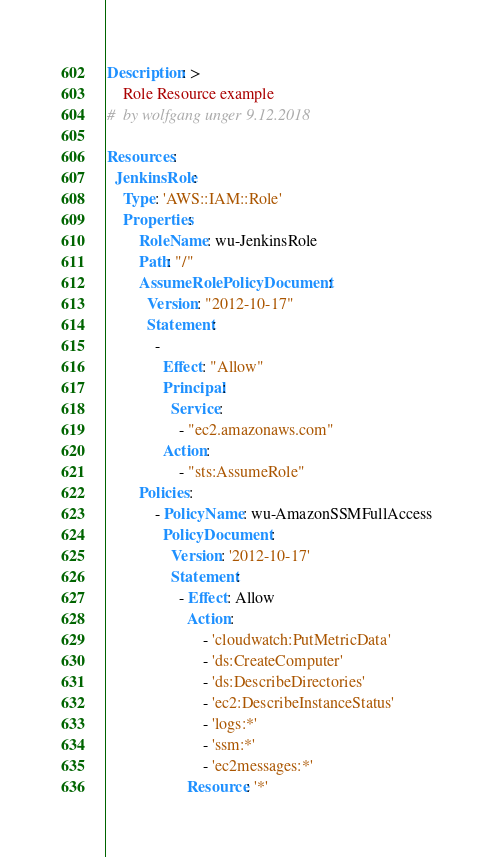<code> <loc_0><loc_0><loc_500><loc_500><_YAML_>
Description: >
    Role Resource example
#  by wolfgang unger 9.12.2018

Resources:
  JenkinsRole:
    Type: 'AWS::IAM::Role'
    Properties:
        RoleName: wu-JenkinsRole    
        Path: "/"    
        AssumeRolePolicyDocument: 
          Version: "2012-10-17"
          Statement: 
            - 
              Effect: "Allow"
              Principal: 
                Service: 
                  - "ec2.amazonaws.com"
              Action: 
                  - "sts:AssumeRole" 
        Policies:
            - PolicyName: wu-AmazonSSMFullAccess
              PolicyDocument:
                Version: '2012-10-17'
                Statement:
                  - Effect: Allow
                    Action:
                        - 'cloudwatch:PutMetricData'
                        - 'ds:CreateComputer'
                        - 'ds:DescribeDirectories'
                        - 'ec2:DescribeInstanceStatus'
                        - 'logs:*'
                        - 'ssm:*'
                        - 'ec2messages:*'
                    Resource: '*'






</code> 